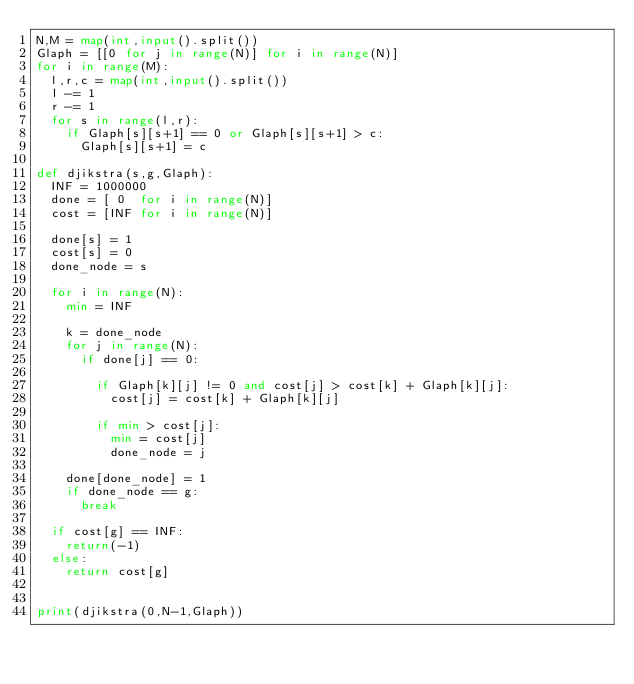<code> <loc_0><loc_0><loc_500><loc_500><_Python_>N,M = map(int,input().split())
Glaph = [[0 for j in range(N)] for i in range(N)]
for i in range(M):
  l,r,c = map(int,input().split())
  l -= 1
  r -= 1
  for s in range(l,r):
    if Glaph[s][s+1] == 0 or Glaph[s][s+1] > c:
      Glaph[s][s+1] = c

def djikstra(s,g,Glaph):
  INF = 1000000
  done = [ 0  for i in range(N)]
  cost = [INF for i in range(N)]
    
  done[s] = 1
  cost[s] = 0
  done_node = s
  
  for i in range(N):
    min = INF
   
    k = done_node 
    for j in range(N):
      if done[j] == 0:
        
        if Glaph[k][j] != 0 and cost[j] > cost[k] + Glaph[k][j]:
          cost[j] = cost[k] + Glaph[k][j]
        
        if min > cost[j]:
          min = cost[j]
          done_node = j
     
    done[done_node] = 1
    if done_node == g:
      break
  
  if cost[g] == INF:
    return(-1)
  else:
    return cost[g]
 
      
print(djikstra(0,N-1,Glaph))</code> 